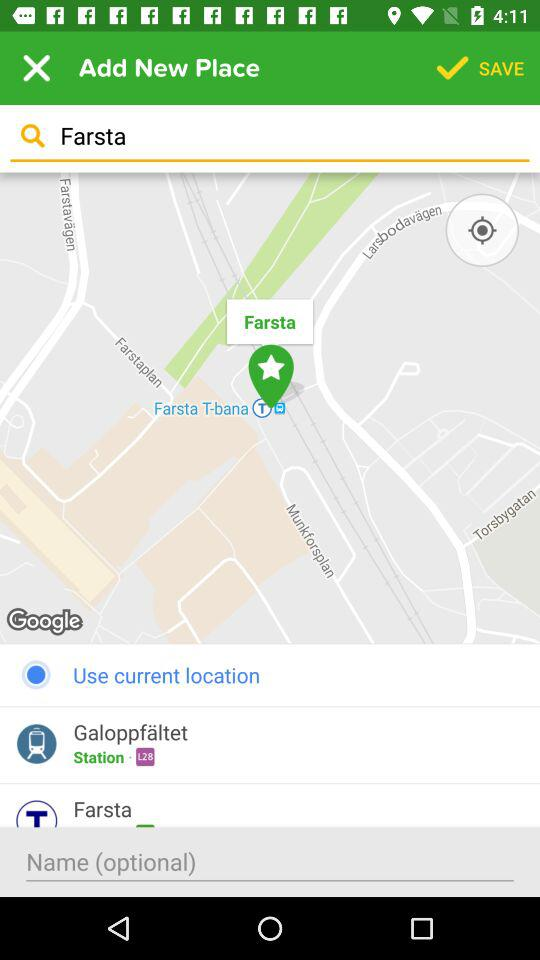What is the searched location? The searched location is "Farsta". 